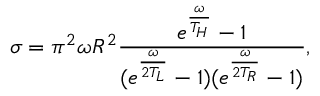Convert formula to latex. <formula><loc_0><loc_0><loc_500><loc_500>\sigma = \pi ^ { 2 } \omega R ^ { 2 } \frac { e ^ { \frac { \omega } { T _ { H } } } - 1 } { ( e ^ { \frac { \omega } { 2 T _ { L } } } - 1 ) ( e ^ { \frac { \omega } { 2 T _ { R } } } - 1 ) } ,</formula> 